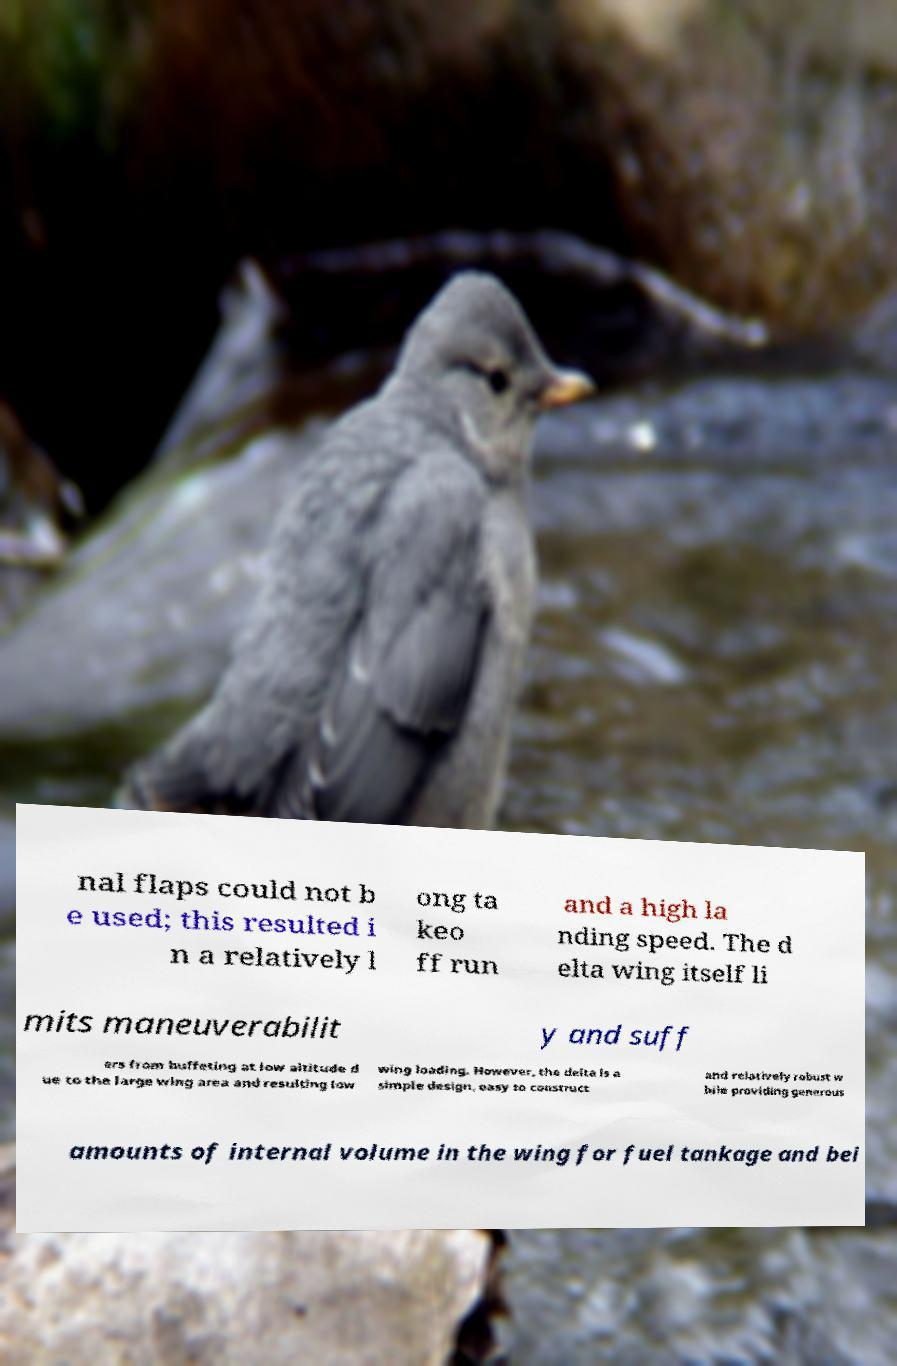For documentation purposes, I need the text within this image transcribed. Could you provide that? nal flaps could not b e used; this resulted i n a relatively l ong ta keo ff run and a high la nding speed. The d elta wing itself li mits maneuverabilit y and suff ers from buffeting at low altitude d ue to the large wing area and resulting low wing loading. However, the delta is a simple design, easy to construct and relatively robust w hile providing generous amounts of internal volume in the wing for fuel tankage and bei 